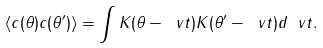<formula> <loc_0><loc_0><loc_500><loc_500>\langle c ( \theta ) c ( \theta ^ { \prime } ) \rangle = \int K ( \theta - \ v t ) K ( \theta ^ { \prime } - \ v t ) d \ v t .</formula> 